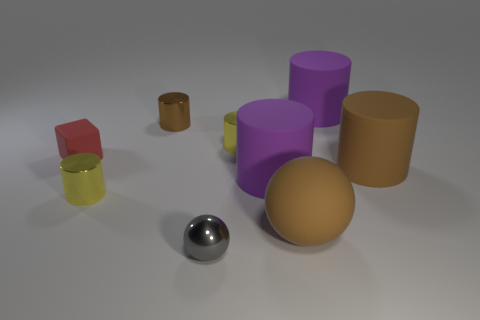Subtract all purple cylinders. How many cylinders are left? 4 Subtract all large purple cylinders. How many cylinders are left? 4 Subtract all green cylinders. Subtract all red balls. How many cylinders are left? 6 Subtract all blocks. How many objects are left? 8 Subtract all tiny gray matte spheres. Subtract all cubes. How many objects are left? 8 Add 6 big brown matte balls. How many big brown matte balls are left? 7 Add 8 large purple cubes. How many large purple cubes exist? 8 Subtract 0 yellow blocks. How many objects are left? 9 